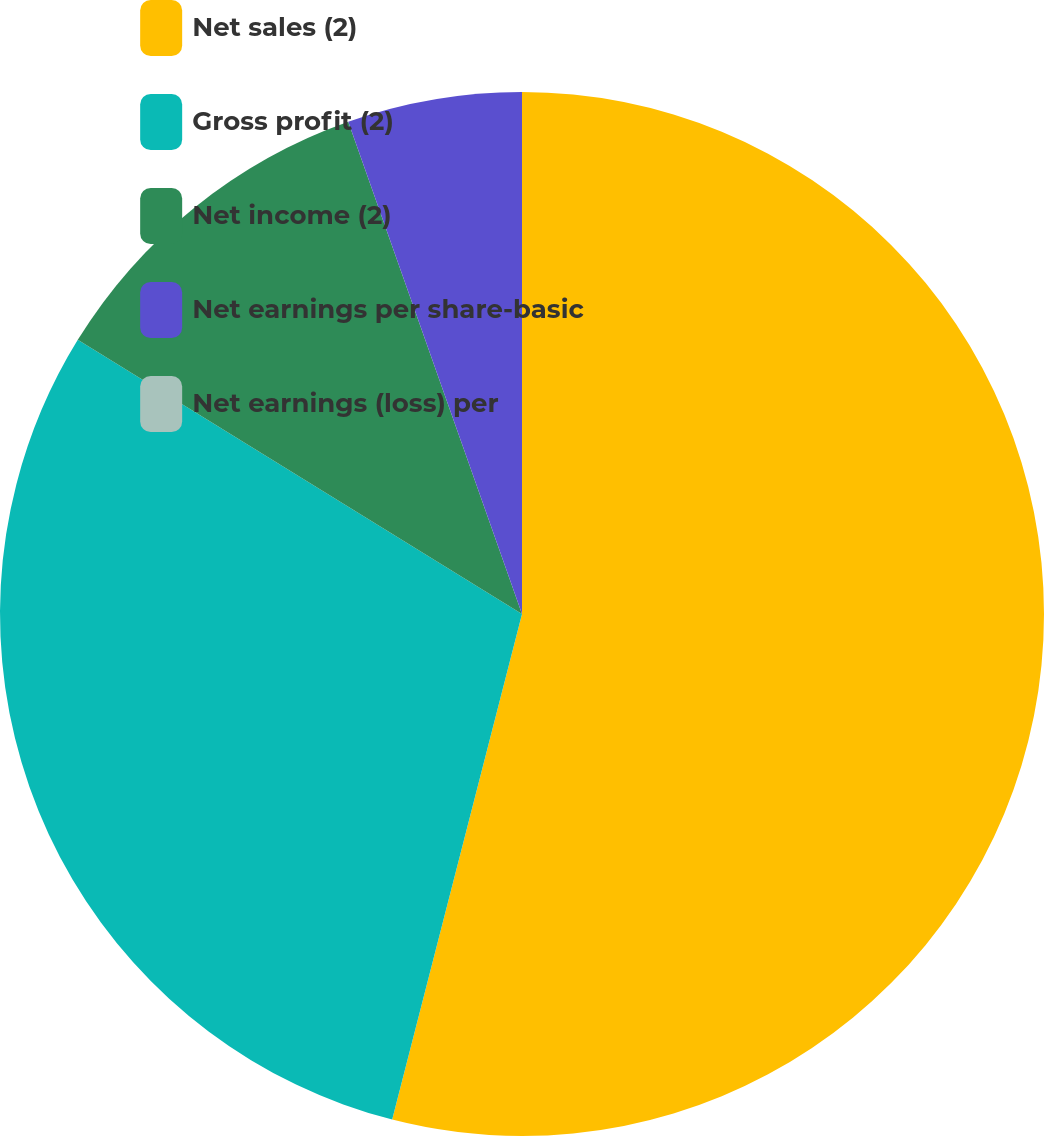Convert chart to OTSL. <chart><loc_0><loc_0><loc_500><loc_500><pie_chart><fcel>Net sales (2)<fcel>Gross profit (2)<fcel>Net income (2)<fcel>Net earnings per share-basic<fcel>Net earnings (loss) per<nl><fcel>54.0%<fcel>29.8%<fcel>10.8%<fcel>5.4%<fcel>0.0%<nl></chart> 